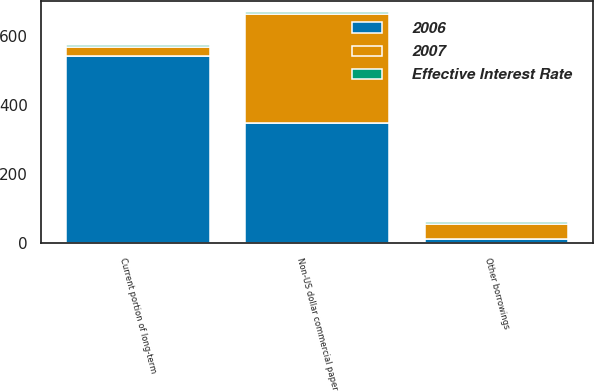Convert chart. <chart><loc_0><loc_0><loc_500><loc_500><stacked_bar_chart><ecel><fcel>Current portion of long-term<fcel>Non-US dollar commercial paper<fcel>Other borrowings<nl><fcel>Effective Interest Rate<fcel>5.37<fcel>4.6<fcel>7.57<nl><fcel>2006<fcel>540<fcel>349<fcel>12<nl><fcel>2007<fcel>27.5<fcel>314<fcel>43<nl></chart> 